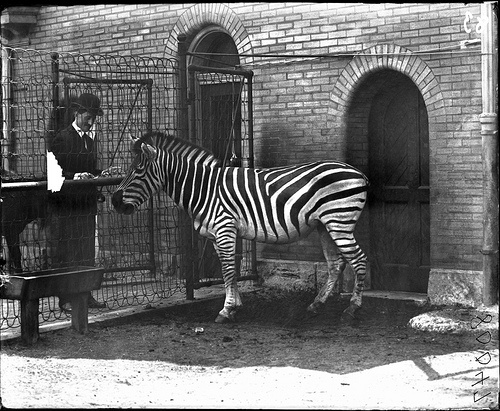Describe the objects in this image and their specific colors. I can see zebra in black, gray, white, and darkgray tones, people in black, gray, white, and darkgray tones, and tie in black tones in this image. 